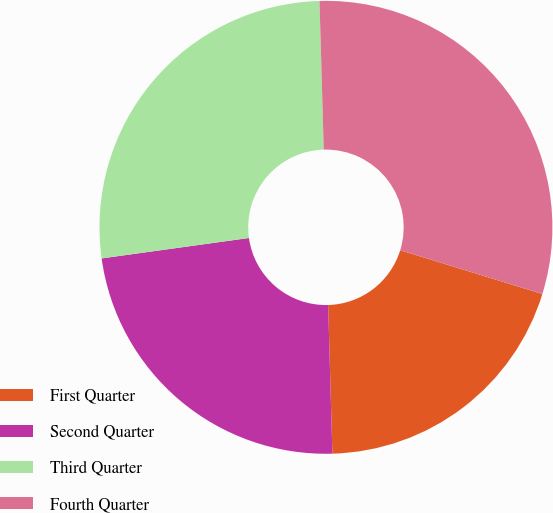<chart> <loc_0><loc_0><loc_500><loc_500><pie_chart><fcel>First Quarter<fcel>Second Quarter<fcel>Third Quarter<fcel>Fourth Quarter<nl><fcel>19.79%<fcel>23.26%<fcel>26.74%<fcel>30.21%<nl></chart> 